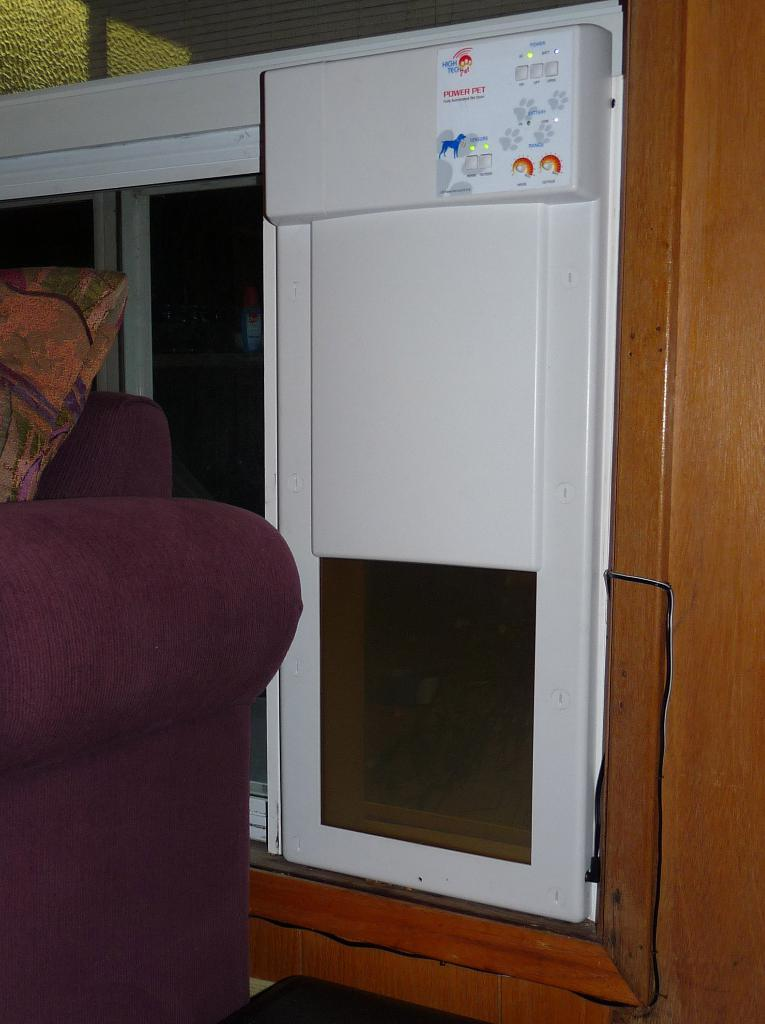What is attached to the wall in the image? There is an electronic device attached to the wall in the image. What can be seen through the windows in the image? The presence of windows suggests that there is a view of the outdoors, but the specific view cannot be determined from the provided facts. What is located on the left side of the image? There is a chair on the left side of the image. What is the purpose of the eggnog in the image? There is no eggnog present in the image, so its purpose cannot be determined. 